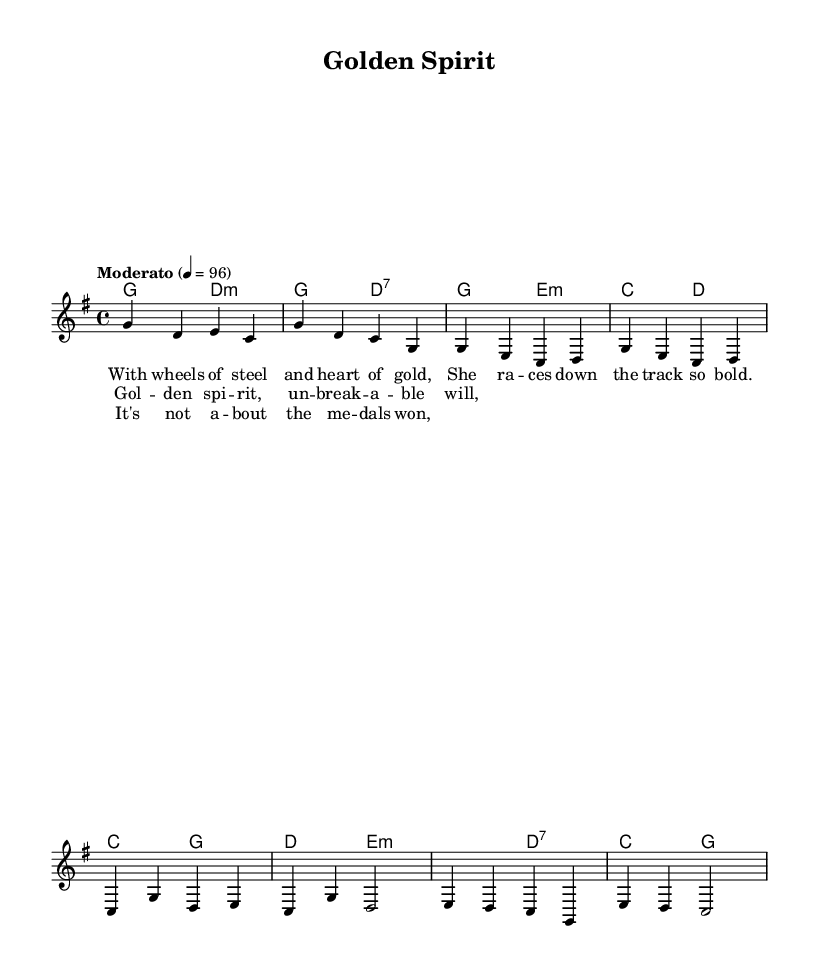What is the key signature of this music? The key signature is G major, which has one sharp (F#). This can be identified from the initial part of the sheet music that specifies the key signature.
Answer: G major What is the time signature of the piece? The time signature is 4/4, which means there are four beats in a measure and the quarter note gets one beat. This can be found at the beginning of the sheet music where the time signature is indicated.
Answer: 4/4 What is the tempo marking in the music? The tempo marking is "Moderato," which generally indicates a moderate pace. The numeric indication of 4 = 96 suggests that there are 96 beats per minute. This information can be gleaned from the tempo marking in the score.
Answer: Moderato Identify the first chord in the score. The first chord in the score is G major. By examining the harmonies line in the chord section, the first chord is labeled as G, indicating a G major harmony.
Answer: G major How many phrases are present in the chorus section? The chorus section consists of two phrases. Each phrase is separated in the lyrics and can be counted from the lyrical layout in the music sheet.
Answer: Two What is the last lyric line in the bridge? The last lyric line in the bridge is "about the medals won." By looking at the lyrics in the bridge section, this line can be directly seen as the conclusion of that part.
Answer: about the medals won What distinguishes folk ballads from other genres in this piece? Folk ballads like this one often tell stories of personal struggle and triumph, specifically highlighting themes such as resilience and overcoming obstacles. This can be inferred from the lyrics and general structure of the song flowing through personal narratives.
Answer: Resilience 